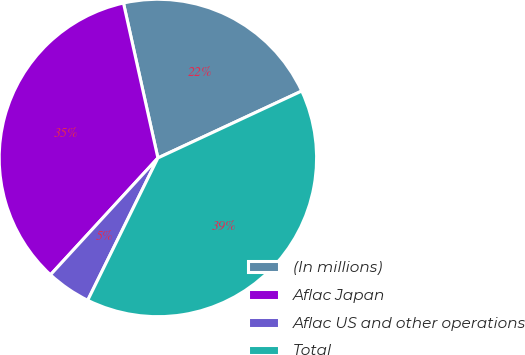Convert chart to OTSL. <chart><loc_0><loc_0><loc_500><loc_500><pie_chart><fcel>(In millions)<fcel>Aflac Japan<fcel>Aflac US and other operations<fcel>Total<nl><fcel>21.55%<fcel>34.69%<fcel>4.54%<fcel>39.23%<nl></chart> 